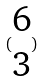Convert formula to latex. <formula><loc_0><loc_0><loc_500><loc_500>( \begin{matrix} 6 \\ 3 \end{matrix} )</formula> 